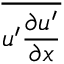Convert formula to latex. <formula><loc_0><loc_0><loc_500><loc_500>\overline { { u ^ { \prime } \frac { \partial u ^ { \prime } } { \partial x } } }</formula> 